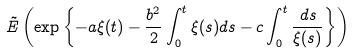<formula> <loc_0><loc_0><loc_500><loc_500>\tilde { E } \left ( \exp \left \{ - a \xi ( t ) - \frac { b ^ { 2 } } { 2 } \int ^ { t } _ { 0 } \xi ( s ) d s - c \int ^ { t } _ { 0 } \frac { d s } { \xi ( s ) } \right \} \right )</formula> 